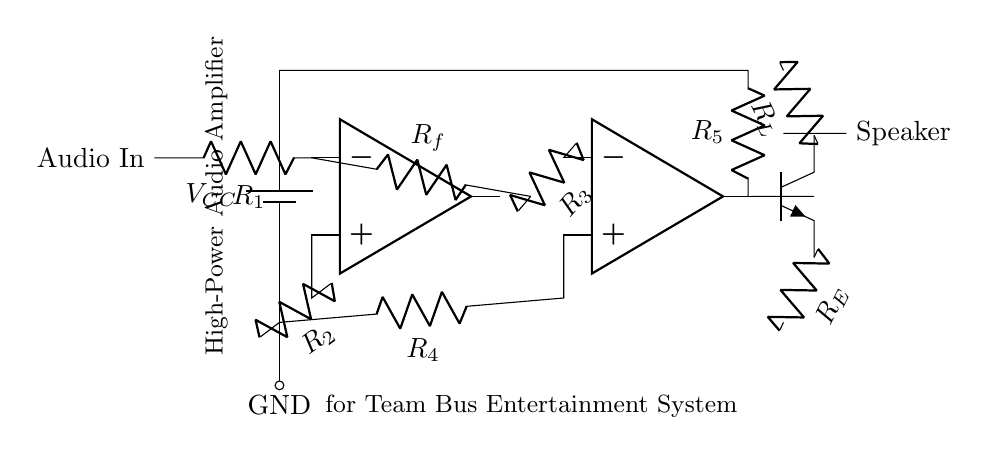What is the main purpose of this circuit? The main purpose of this circuit is to amplify audio signals for entertainment systems in a team bus environment. This can be inferred from the label provided in the diagram which states it's a high-power audio amplifier targeted for team bus entertainment.
Answer: audio amplification What is the type of output device used in this amplifier circuit? The output device used in this amplifier circuit is a speaker, indicated at the end of the circuit diagram where it is connected to the output of the transistor. This shows that the amplified audio signal is intended to drive an audio output medium.
Answer: speaker What component is used for voltage gain in this circuit? The operational amplifiers (op amps) in the circuit are primarily used for voltage gain; they amplify the input audio signal to a higher level. This can be determined by observing the input stage and driver stage, both consisting of op amps.
Answer: operational amplifier Which resistor connects the output of the first op-amp to the input of the second op-amp? The resistor that connects the output of the first op-amp to the input of the second op-amp is called R3. This can be seen where R3 is drawn between the output of the first op-amp and the input of the second op-amp.
Answer: R3 What is the function of the resistor labeled R_E in this circuit? The resistor labeled R_E serves as the emitter resistor for the output transistor (Q1). It is used to stabilize the transistor's operation and set the output current by developing a voltage drop proportional to the current flowing through it, as indicated in general transistor amplifier configurations.
Answer: emitter stabilization How does R_f affect the gain of the amplifier? R_f, also known as the feedback resistor, plays a critical role in determining the gain of the amplifier. The configuration of the feedback network, which involves R_f and R1, sets the closed-loop gain of the operational amplifier. The gain can be calculated based on the ratio of R_f to R_1 in the feedback loop, implied by the circuit design.
Answer: gain setting What is the function of R_L in this circuit? R_L acts as the load resistor for the amplifier circuit. It absorbs the amplified power from the output stage, which is necessary for driving the speaker. In this diagram, it connects the collector of the output transistor to the power supply, indicating its role in supporting the load of the audio output.
Answer: load resistor 